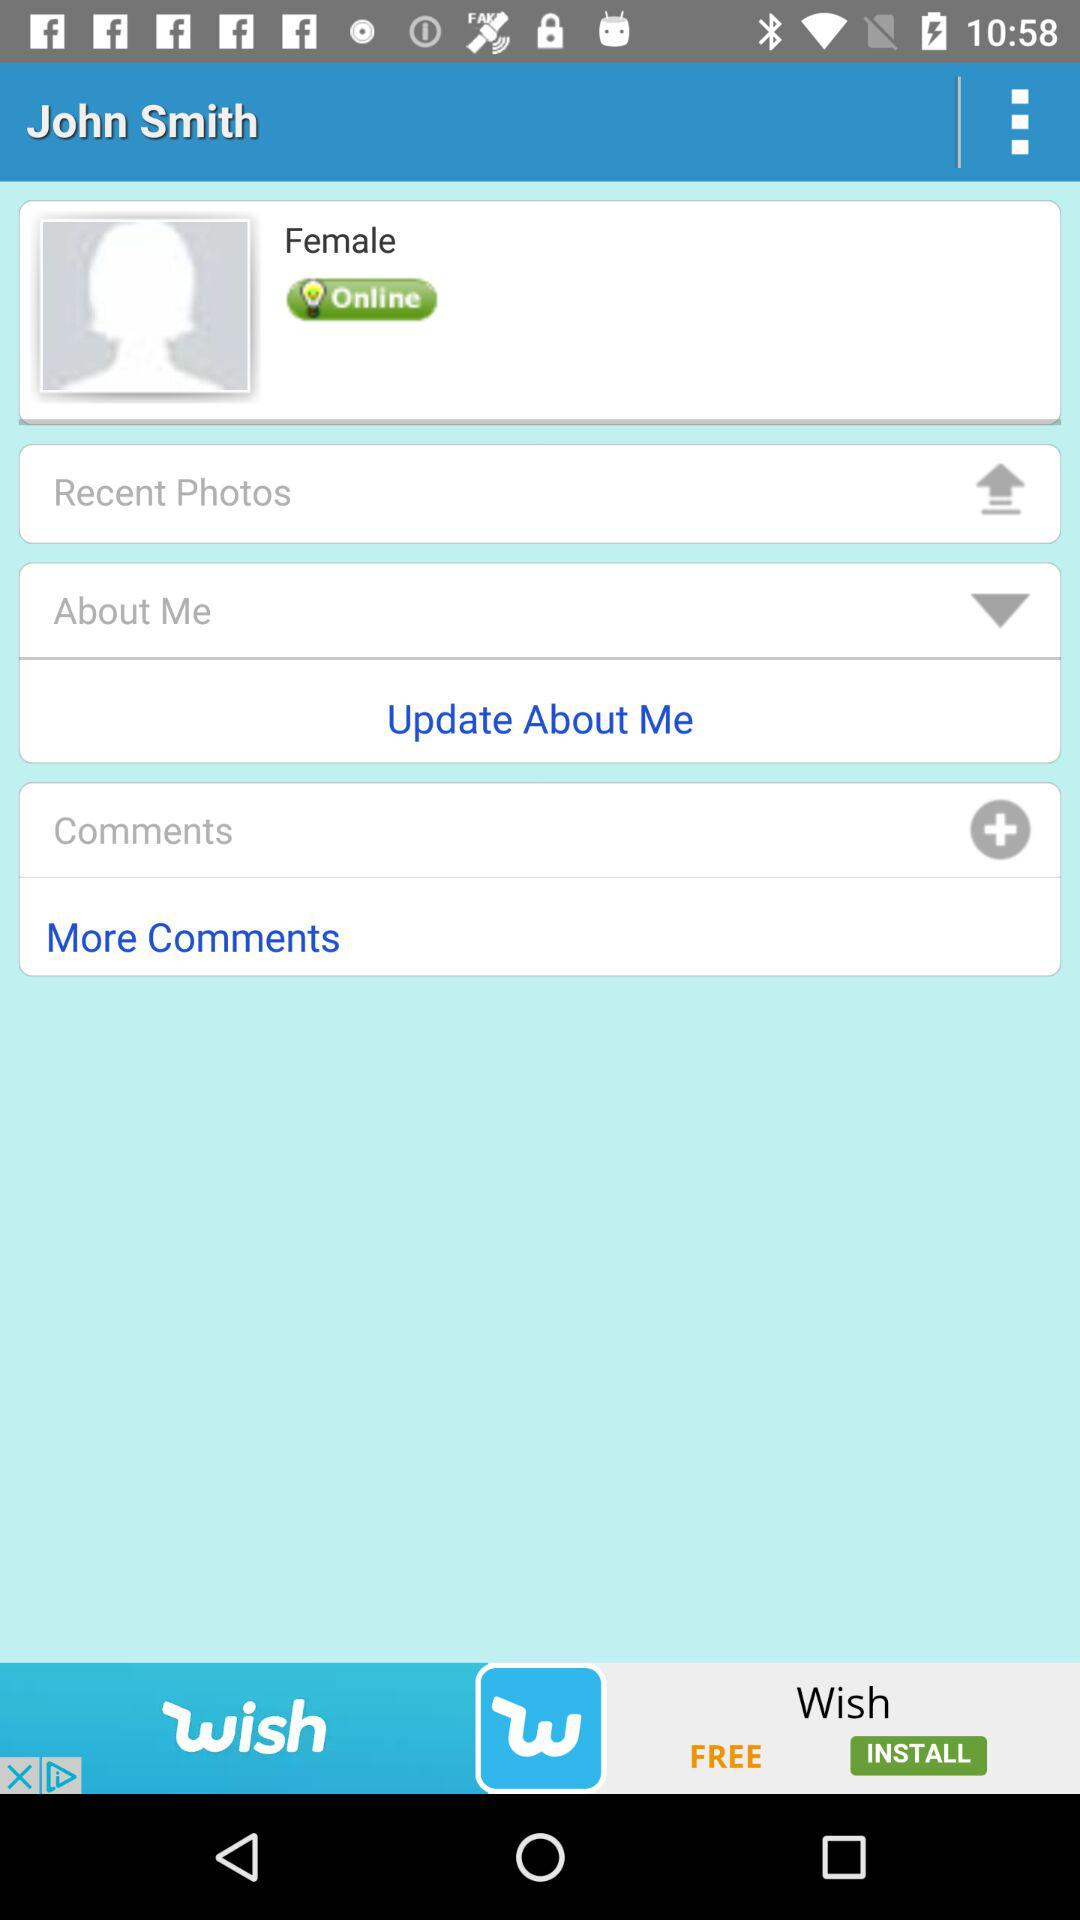What is the user's name? The user's name is John Smith. 